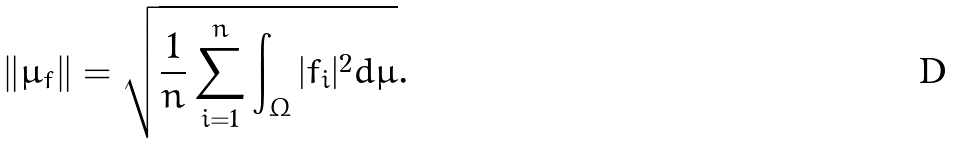<formula> <loc_0><loc_0><loc_500><loc_500>\| \mu _ { f } \| = \sqrt { \frac { 1 } { n } \sum _ { i = 1 } ^ { n } \int _ { \Omega } | f _ { i } | ^ { 2 } d \mu } .</formula> 